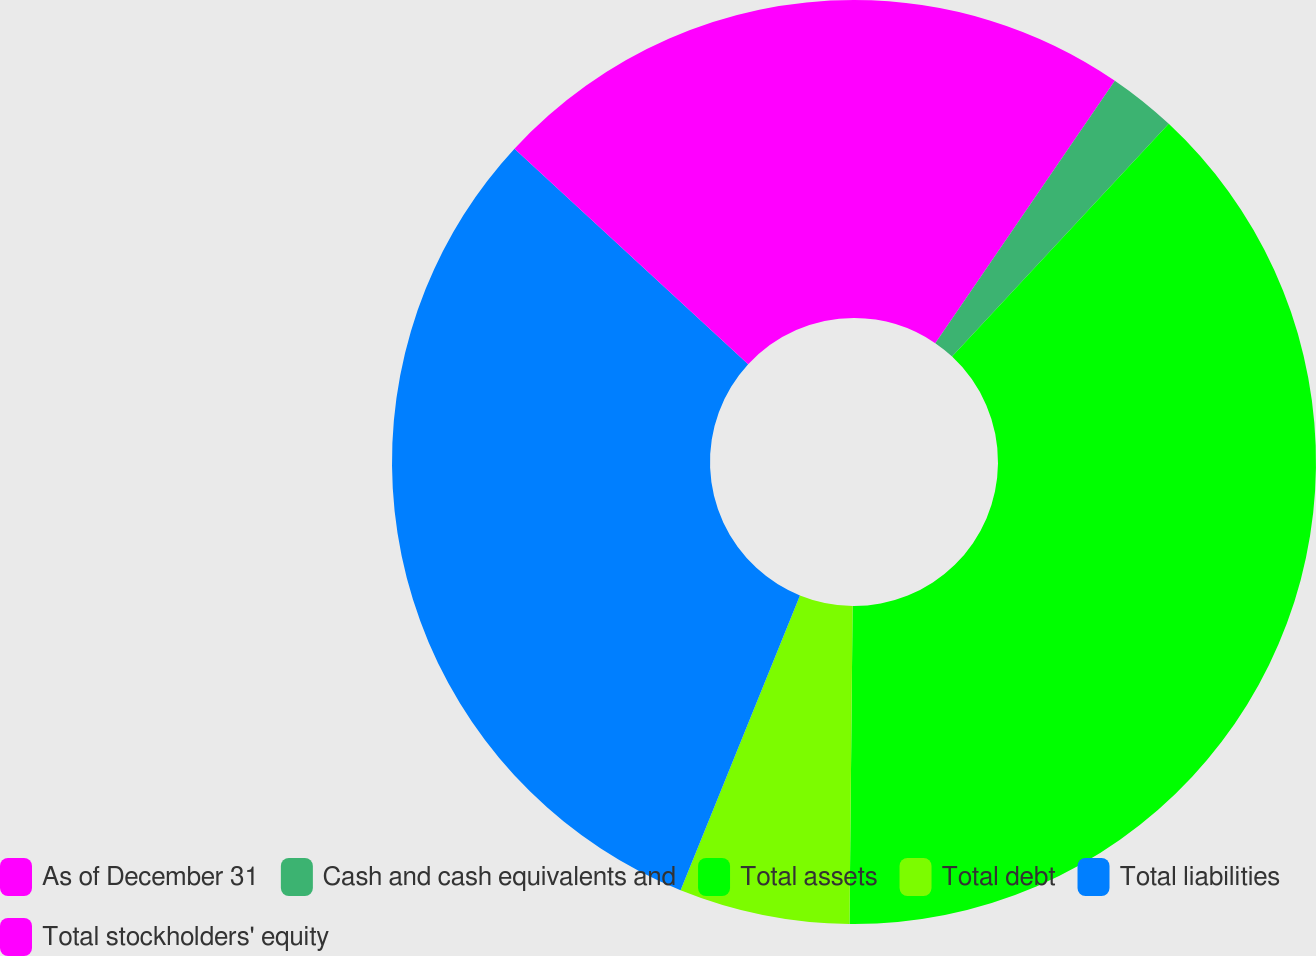Convert chart. <chart><loc_0><loc_0><loc_500><loc_500><pie_chart><fcel>As of December 31<fcel>Cash and cash equivalents and<fcel>Total assets<fcel>Total debt<fcel>Total liabilities<fcel>Total stockholders' equity<nl><fcel>9.55%<fcel>2.38%<fcel>38.23%<fcel>5.97%<fcel>30.74%<fcel>13.14%<nl></chart> 